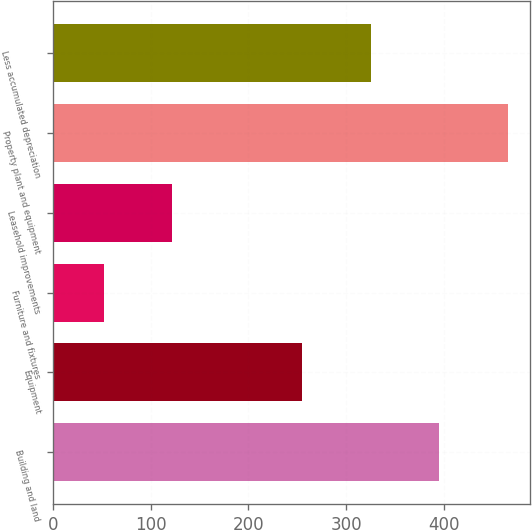<chart> <loc_0><loc_0><loc_500><loc_500><bar_chart><fcel>Building and land<fcel>Equipment<fcel>Furniture and fixtures<fcel>Leasehold improvements<fcel>Property plant and equipment<fcel>Less accumulated depreciation<nl><fcel>395.2<fcel>255<fcel>52<fcel>122.1<fcel>465.3<fcel>325.1<nl></chart> 